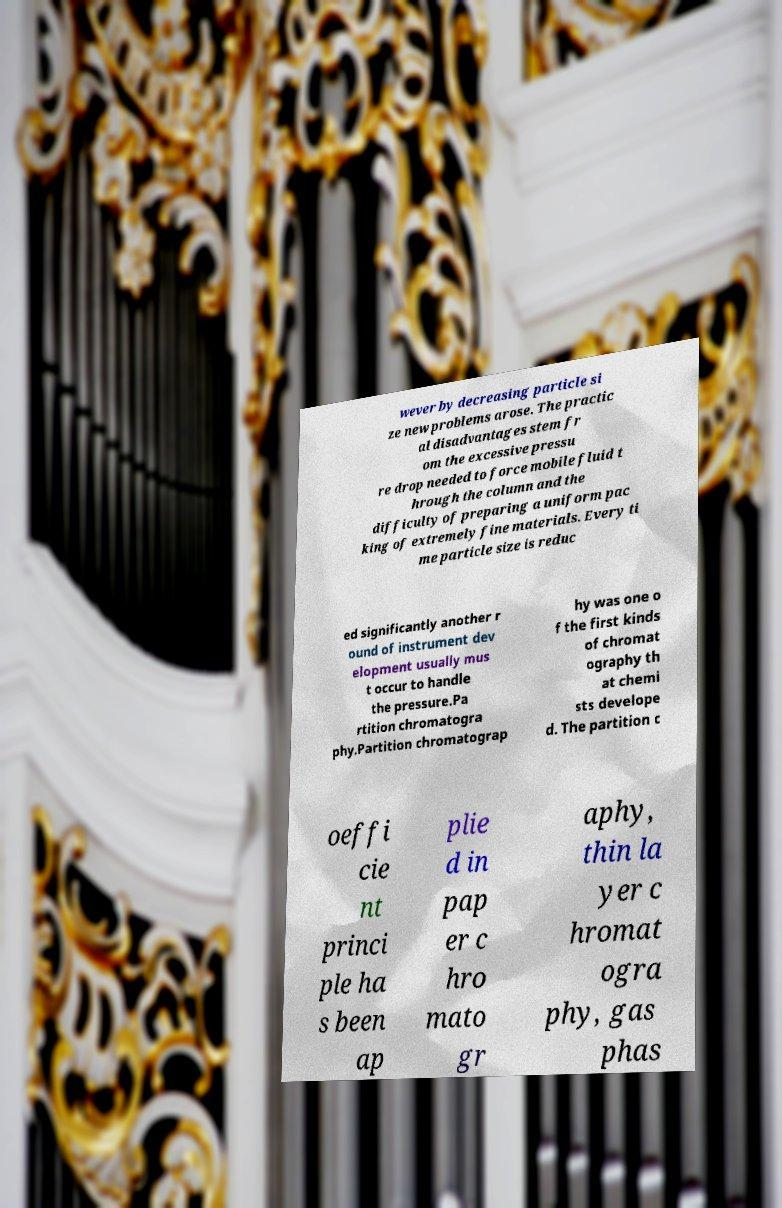What messages or text are displayed in this image? I need them in a readable, typed format. wever by decreasing particle si ze new problems arose. The practic al disadvantages stem fr om the excessive pressu re drop needed to force mobile fluid t hrough the column and the difficulty of preparing a uniform pac king of extremely fine materials. Every ti me particle size is reduc ed significantly another r ound of instrument dev elopment usually mus t occur to handle the pressure.Pa rtition chromatogra phy.Partition chromatograp hy was one o f the first kinds of chromat ography th at chemi sts develope d. The partition c oeffi cie nt princi ple ha s been ap plie d in pap er c hro mato gr aphy, thin la yer c hromat ogra phy, gas phas 